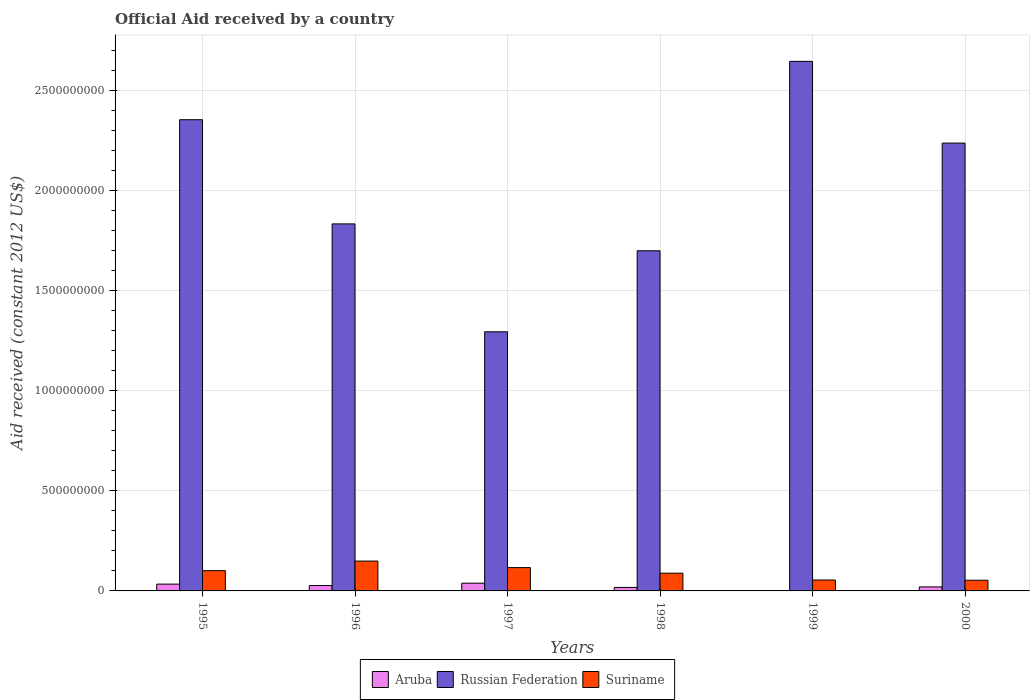How many different coloured bars are there?
Make the answer very short. 3. How many groups of bars are there?
Your answer should be very brief. 6. Are the number of bars on each tick of the X-axis equal?
Provide a short and direct response. No. How many bars are there on the 2nd tick from the left?
Offer a terse response. 3. In how many cases, is the number of bars for a given year not equal to the number of legend labels?
Offer a very short reply. 1. What is the net official aid received in Aruba in 1995?
Offer a very short reply. 3.40e+07. Across all years, what is the maximum net official aid received in Aruba?
Keep it short and to the point. 3.87e+07. Across all years, what is the minimum net official aid received in Aruba?
Provide a succinct answer. 0. What is the total net official aid received in Suriname in the graph?
Keep it short and to the point. 5.64e+08. What is the difference between the net official aid received in Russian Federation in 1996 and that in 1998?
Give a very brief answer. 1.34e+08. What is the difference between the net official aid received in Russian Federation in 1998 and the net official aid received in Aruba in 1995?
Your answer should be compact. 1.67e+09. What is the average net official aid received in Suriname per year?
Make the answer very short. 9.39e+07. In the year 1995, what is the difference between the net official aid received in Russian Federation and net official aid received in Aruba?
Ensure brevity in your answer.  2.32e+09. What is the ratio of the net official aid received in Russian Federation in 1997 to that in 1999?
Keep it short and to the point. 0.49. Is the difference between the net official aid received in Russian Federation in 1997 and 1998 greater than the difference between the net official aid received in Aruba in 1997 and 1998?
Offer a terse response. No. What is the difference between the highest and the second highest net official aid received in Russian Federation?
Offer a very short reply. 2.92e+08. What is the difference between the highest and the lowest net official aid received in Suriname?
Your answer should be very brief. 9.58e+07. Is it the case that in every year, the sum of the net official aid received in Aruba and net official aid received in Suriname is greater than the net official aid received in Russian Federation?
Your answer should be compact. No. How many bars are there?
Ensure brevity in your answer.  17. How many years are there in the graph?
Offer a terse response. 6. What is the difference between two consecutive major ticks on the Y-axis?
Offer a terse response. 5.00e+08. Are the values on the major ticks of Y-axis written in scientific E-notation?
Your answer should be compact. No. Does the graph contain any zero values?
Keep it short and to the point. Yes. Does the graph contain grids?
Your answer should be very brief. Yes. How are the legend labels stacked?
Your response must be concise. Horizontal. What is the title of the graph?
Your response must be concise. Official Aid received by a country. Does "Lao PDR" appear as one of the legend labels in the graph?
Give a very brief answer. No. What is the label or title of the X-axis?
Provide a succinct answer. Years. What is the label or title of the Y-axis?
Make the answer very short. Aid received (constant 2012 US$). What is the Aid received (constant 2012 US$) of Aruba in 1995?
Provide a succinct answer. 3.40e+07. What is the Aid received (constant 2012 US$) of Russian Federation in 1995?
Offer a very short reply. 2.36e+09. What is the Aid received (constant 2012 US$) in Suriname in 1995?
Provide a short and direct response. 1.01e+08. What is the Aid received (constant 2012 US$) of Aruba in 1996?
Provide a succinct answer. 2.68e+07. What is the Aid received (constant 2012 US$) in Russian Federation in 1996?
Offer a terse response. 1.84e+09. What is the Aid received (constant 2012 US$) in Suriname in 1996?
Provide a short and direct response. 1.49e+08. What is the Aid received (constant 2012 US$) of Aruba in 1997?
Keep it short and to the point. 3.87e+07. What is the Aid received (constant 2012 US$) in Russian Federation in 1997?
Make the answer very short. 1.30e+09. What is the Aid received (constant 2012 US$) of Suriname in 1997?
Give a very brief answer. 1.17e+08. What is the Aid received (constant 2012 US$) in Aruba in 1998?
Keep it short and to the point. 1.74e+07. What is the Aid received (constant 2012 US$) in Russian Federation in 1998?
Give a very brief answer. 1.70e+09. What is the Aid received (constant 2012 US$) of Suriname in 1998?
Ensure brevity in your answer.  8.86e+07. What is the Aid received (constant 2012 US$) of Russian Federation in 1999?
Your answer should be compact. 2.65e+09. What is the Aid received (constant 2012 US$) in Suriname in 1999?
Make the answer very short. 5.45e+07. What is the Aid received (constant 2012 US$) of Aruba in 2000?
Your answer should be compact. 2.01e+07. What is the Aid received (constant 2012 US$) in Russian Federation in 2000?
Your answer should be compact. 2.24e+09. What is the Aid received (constant 2012 US$) of Suriname in 2000?
Your answer should be very brief. 5.34e+07. Across all years, what is the maximum Aid received (constant 2012 US$) in Aruba?
Your response must be concise. 3.87e+07. Across all years, what is the maximum Aid received (constant 2012 US$) in Russian Federation?
Provide a short and direct response. 2.65e+09. Across all years, what is the maximum Aid received (constant 2012 US$) of Suriname?
Provide a short and direct response. 1.49e+08. Across all years, what is the minimum Aid received (constant 2012 US$) of Aruba?
Provide a succinct answer. 0. Across all years, what is the minimum Aid received (constant 2012 US$) of Russian Federation?
Offer a terse response. 1.30e+09. Across all years, what is the minimum Aid received (constant 2012 US$) in Suriname?
Your answer should be compact. 5.34e+07. What is the total Aid received (constant 2012 US$) of Aruba in the graph?
Offer a very short reply. 1.37e+08. What is the total Aid received (constant 2012 US$) of Russian Federation in the graph?
Offer a very short reply. 1.21e+1. What is the total Aid received (constant 2012 US$) in Suriname in the graph?
Offer a terse response. 5.64e+08. What is the difference between the Aid received (constant 2012 US$) in Aruba in 1995 and that in 1996?
Give a very brief answer. 7.17e+06. What is the difference between the Aid received (constant 2012 US$) of Russian Federation in 1995 and that in 1996?
Offer a terse response. 5.21e+08. What is the difference between the Aid received (constant 2012 US$) of Suriname in 1995 and that in 1996?
Offer a terse response. -4.78e+07. What is the difference between the Aid received (constant 2012 US$) in Aruba in 1995 and that in 1997?
Make the answer very short. -4.66e+06. What is the difference between the Aid received (constant 2012 US$) in Russian Federation in 1995 and that in 1997?
Give a very brief answer. 1.06e+09. What is the difference between the Aid received (constant 2012 US$) in Suriname in 1995 and that in 1997?
Your response must be concise. -1.52e+07. What is the difference between the Aid received (constant 2012 US$) in Aruba in 1995 and that in 1998?
Offer a very short reply. 1.67e+07. What is the difference between the Aid received (constant 2012 US$) of Russian Federation in 1995 and that in 1998?
Offer a very short reply. 6.55e+08. What is the difference between the Aid received (constant 2012 US$) of Suriname in 1995 and that in 1998?
Keep it short and to the point. 1.28e+07. What is the difference between the Aid received (constant 2012 US$) in Russian Federation in 1995 and that in 1999?
Give a very brief answer. -2.92e+08. What is the difference between the Aid received (constant 2012 US$) of Suriname in 1995 and that in 1999?
Your response must be concise. 4.69e+07. What is the difference between the Aid received (constant 2012 US$) of Aruba in 1995 and that in 2000?
Make the answer very short. 1.39e+07. What is the difference between the Aid received (constant 2012 US$) of Russian Federation in 1995 and that in 2000?
Ensure brevity in your answer.  1.17e+08. What is the difference between the Aid received (constant 2012 US$) in Suriname in 1995 and that in 2000?
Provide a short and direct response. 4.80e+07. What is the difference between the Aid received (constant 2012 US$) of Aruba in 1996 and that in 1997?
Offer a terse response. -1.18e+07. What is the difference between the Aid received (constant 2012 US$) of Russian Federation in 1996 and that in 1997?
Provide a succinct answer. 5.39e+08. What is the difference between the Aid received (constant 2012 US$) of Suriname in 1996 and that in 1997?
Keep it short and to the point. 3.26e+07. What is the difference between the Aid received (constant 2012 US$) of Aruba in 1996 and that in 1998?
Make the answer very short. 9.50e+06. What is the difference between the Aid received (constant 2012 US$) in Russian Federation in 1996 and that in 1998?
Your answer should be very brief. 1.34e+08. What is the difference between the Aid received (constant 2012 US$) of Suriname in 1996 and that in 1998?
Provide a short and direct response. 6.06e+07. What is the difference between the Aid received (constant 2012 US$) of Russian Federation in 1996 and that in 1999?
Provide a short and direct response. -8.13e+08. What is the difference between the Aid received (constant 2012 US$) in Suriname in 1996 and that in 1999?
Your answer should be compact. 9.46e+07. What is the difference between the Aid received (constant 2012 US$) of Aruba in 1996 and that in 2000?
Offer a very short reply. 6.72e+06. What is the difference between the Aid received (constant 2012 US$) in Russian Federation in 1996 and that in 2000?
Keep it short and to the point. -4.04e+08. What is the difference between the Aid received (constant 2012 US$) in Suriname in 1996 and that in 2000?
Offer a terse response. 9.58e+07. What is the difference between the Aid received (constant 2012 US$) in Aruba in 1997 and that in 1998?
Offer a terse response. 2.13e+07. What is the difference between the Aid received (constant 2012 US$) in Russian Federation in 1997 and that in 1998?
Your response must be concise. -4.05e+08. What is the difference between the Aid received (constant 2012 US$) of Suriname in 1997 and that in 1998?
Make the answer very short. 2.80e+07. What is the difference between the Aid received (constant 2012 US$) of Russian Federation in 1997 and that in 1999?
Your response must be concise. -1.35e+09. What is the difference between the Aid received (constant 2012 US$) of Suriname in 1997 and that in 1999?
Provide a short and direct response. 6.21e+07. What is the difference between the Aid received (constant 2012 US$) of Aruba in 1997 and that in 2000?
Ensure brevity in your answer.  1.86e+07. What is the difference between the Aid received (constant 2012 US$) of Russian Federation in 1997 and that in 2000?
Offer a terse response. -9.44e+08. What is the difference between the Aid received (constant 2012 US$) of Suriname in 1997 and that in 2000?
Your answer should be compact. 6.32e+07. What is the difference between the Aid received (constant 2012 US$) in Russian Federation in 1998 and that in 1999?
Give a very brief answer. -9.47e+08. What is the difference between the Aid received (constant 2012 US$) in Suriname in 1998 and that in 1999?
Keep it short and to the point. 3.41e+07. What is the difference between the Aid received (constant 2012 US$) of Aruba in 1998 and that in 2000?
Keep it short and to the point. -2.78e+06. What is the difference between the Aid received (constant 2012 US$) of Russian Federation in 1998 and that in 2000?
Ensure brevity in your answer.  -5.38e+08. What is the difference between the Aid received (constant 2012 US$) in Suriname in 1998 and that in 2000?
Offer a terse response. 3.52e+07. What is the difference between the Aid received (constant 2012 US$) in Russian Federation in 1999 and that in 2000?
Give a very brief answer. 4.09e+08. What is the difference between the Aid received (constant 2012 US$) of Suriname in 1999 and that in 2000?
Offer a very short reply. 1.18e+06. What is the difference between the Aid received (constant 2012 US$) of Aruba in 1995 and the Aid received (constant 2012 US$) of Russian Federation in 1996?
Your response must be concise. -1.80e+09. What is the difference between the Aid received (constant 2012 US$) in Aruba in 1995 and the Aid received (constant 2012 US$) in Suriname in 1996?
Ensure brevity in your answer.  -1.15e+08. What is the difference between the Aid received (constant 2012 US$) of Russian Federation in 1995 and the Aid received (constant 2012 US$) of Suriname in 1996?
Make the answer very short. 2.21e+09. What is the difference between the Aid received (constant 2012 US$) of Aruba in 1995 and the Aid received (constant 2012 US$) of Russian Federation in 1997?
Your response must be concise. -1.26e+09. What is the difference between the Aid received (constant 2012 US$) of Aruba in 1995 and the Aid received (constant 2012 US$) of Suriname in 1997?
Give a very brief answer. -8.26e+07. What is the difference between the Aid received (constant 2012 US$) in Russian Federation in 1995 and the Aid received (constant 2012 US$) in Suriname in 1997?
Give a very brief answer. 2.24e+09. What is the difference between the Aid received (constant 2012 US$) in Aruba in 1995 and the Aid received (constant 2012 US$) in Russian Federation in 1998?
Provide a succinct answer. -1.67e+09. What is the difference between the Aid received (constant 2012 US$) of Aruba in 1995 and the Aid received (constant 2012 US$) of Suriname in 1998?
Offer a very short reply. -5.46e+07. What is the difference between the Aid received (constant 2012 US$) in Russian Federation in 1995 and the Aid received (constant 2012 US$) in Suriname in 1998?
Offer a very short reply. 2.27e+09. What is the difference between the Aid received (constant 2012 US$) in Aruba in 1995 and the Aid received (constant 2012 US$) in Russian Federation in 1999?
Keep it short and to the point. -2.61e+09. What is the difference between the Aid received (constant 2012 US$) in Aruba in 1995 and the Aid received (constant 2012 US$) in Suriname in 1999?
Ensure brevity in your answer.  -2.05e+07. What is the difference between the Aid received (constant 2012 US$) of Russian Federation in 1995 and the Aid received (constant 2012 US$) of Suriname in 1999?
Give a very brief answer. 2.30e+09. What is the difference between the Aid received (constant 2012 US$) of Aruba in 1995 and the Aid received (constant 2012 US$) of Russian Federation in 2000?
Your answer should be very brief. -2.21e+09. What is the difference between the Aid received (constant 2012 US$) in Aruba in 1995 and the Aid received (constant 2012 US$) in Suriname in 2000?
Keep it short and to the point. -1.93e+07. What is the difference between the Aid received (constant 2012 US$) of Russian Federation in 1995 and the Aid received (constant 2012 US$) of Suriname in 2000?
Your answer should be compact. 2.30e+09. What is the difference between the Aid received (constant 2012 US$) of Aruba in 1996 and the Aid received (constant 2012 US$) of Russian Federation in 1997?
Your response must be concise. -1.27e+09. What is the difference between the Aid received (constant 2012 US$) in Aruba in 1996 and the Aid received (constant 2012 US$) in Suriname in 1997?
Provide a succinct answer. -8.98e+07. What is the difference between the Aid received (constant 2012 US$) of Russian Federation in 1996 and the Aid received (constant 2012 US$) of Suriname in 1997?
Give a very brief answer. 1.72e+09. What is the difference between the Aid received (constant 2012 US$) of Aruba in 1996 and the Aid received (constant 2012 US$) of Russian Federation in 1998?
Offer a very short reply. -1.67e+09. What is the difference between the Aid received (constant 2012 US$) of Aruba in 1996 and the Aid received (constant 2012 US$) of Suriname in 1998?
Offer a terse response. -6.18e+07. What is the difference between the Aid received (constant 2012 US$) in Russian Federation in 1996 and the Aid received (constant 2012 US$) in Suriname in 1998?
Offer a terse response. 1.75e+09. What is the difference between the Aid received (constant 2012 US$) in Aruba in 1996 and the Aid received (constant 2012 US$) in Russian Federation in 1999?
Ensure brevity in your answer.  -2.62e+09. What is the difference between the Aid received (constant 2012 US$) in Aruba in 1996 and the Aid received (constant 2012 US$) in Suriname in 1999?
Make the answer very short. -2.77e+07. What is the difference between the Aid received (constant 2012 US$) of Russian Federation in 1996 and the Aid received (constant 2012 US$) of Suriname in 1999?
Give a very brief answer. 1.78e+09. What is the difference between the Aid received (constant 2012 US$) in Aruba in 1996 and the Aid received (constant 2012 US$) in Russian Federation in 2000?
Your response must be concise. -2.21e+09. What is the difference between the Aid received (constant 2012 US$) of Aruba in 1996 and the Aid received (constant 2012 US$) of Suriname in 2000?
Keep it short and to the point. -2.65e+07. What is the difference between the Aid received (constant 2012 US$) of Russian Federation in 1996 and the Aid received (constant 2012 US$) of Suriname in 2000?
Offer a very short reply. 1.78e+09. What is the difference between the Aid received (constant 2012 US$) of Aruba in 1997 and the Aid received (constant 2012 US$) of Russian Federation in 1998?
Ensure brevity in your answer.  -1.66e+09. What is the difference between the Aid received (constant 2012 US$) in Aruba in 1997 and the Aid received (constant 2012 US$) in Suriname in 1998?
Ensure brevity in your answer.  -4.99e+07. What is the difference between the Aid received (constant 2012 US$) of Russian Federation in 1997 and the Aid received (constant 2012 US$) of Suriname in 1998?
Ensure brevity in your answer.  1.21e+09. What is the difference between the Aid received (constant 2012 US$) of Aruba in 1997 and the Aid received (constant 2012 US$) of Russian Federation in 1999?
Offer a terse response. -2.61e+09. What is the difference between the Aid received (constant 2012 US$) in Aruba in 1997 and the Aid received (constant 2012 US$) in Suriname in 1999?
Offer a terse response. -1.59e+07. What is the difference between the Aid received (constant 2012 US$) of Russian Federation in 1997 and the Aid received (constant 2012 US$) of Suriname in 1999?
Provide a short and direct response. 1.24e+09. What is the difference between the Aid received (constant 2012 US$) of Aruba in 1997 and the Aid received (constant 2012 US$) of Russian Federation in 2000?
Provide a succinct answer. -2.20e+09. What is the difference between the Aid received (constant 2012 US$) in Aruba in 1997 and the Aid received (constant 2012 US$) in Suriname in 2000?
Provide a short and direct response. -1.47e+07. What is the difference between the Aid received (constant 2012 US$) in Russian Federation in 1997 and the Aid received (constant 2012 US$) in Suriname in 2000?
Your answer should be very brief. 1.24e+09. What is the difference between the Aid received (constant 2012 US$) in Aruba in 1998 and the Aid received (constant 2012 US$) in Russian Federation in 1999?
Provide a short and direct response. -2.63e+09. What is the difference between the Aid received (constant 2012 US$) in Aruba in 1998 and the Aid received (constant 2012 US$) in Suriname in 1999?
Your response must be concise. -3.72e+07. What is the difference between the Aid received (constant 2012 US$) of Russian Federation in 1998 and the Aid received (constant 2012 US$) of Suriname in 1999?
Offer a very short reply. 1.65e+09. What is the difference between the Aid received (constant 2012 US$) of Aruba in 1998 and the Aid received (constant 2012 US$) of Russian Federation in 2000?
Offer a terse response. -2.22e+09. What is the difference between the Aid received (constant 2012 US$) in Aruba in 1998 and the Aid received (constant 2012 US$) in Suriname in 2000?
Provide a short and direct response. -3.60e+07. What is the difference between the Aid received (constant 2012 US$) of Russian Federation in 1998 and the Aid received (constant 2012 US$) of Suriname in 2000?
Provide a short and direct response. 1.65e+09. What is the difference between the Aid received (constant 2012 US$) of Russian Federation in 1999 and the Aid received (constant 2012 US$) of Suriname in 2000?
Keep it short and to the point. 2.59e+09. What is the average Aid received (constant 2012 US$) of Aruba per year?
Offer a terse response. 2.28e+07. What is the average Aid received (constant 2012 US$) of Russian Federation per year?
Your response must be concise. 2.01e+09. What is the average Aid received (constant 2012 US$) of Suriname per year?
Provide a succinct answer. 9.39e+07. In the year 1995, what is the difference between the Aid received (constant 2012 US$) in Aruba and Aid received (constant 2012 US$) in Russian Federation?
Provide a short and direct response. -2.32e+09. In the year 1995, what is the difference between the Aid received (constant 2012 US$) of Aruba and Aid received (constant 2012 US$) of Suriname?
Provide a succinct answer. -6.74e+07. In the year 1995, what is the difference between the Aid received (constant 2012 US$) of Russian Federation and Aid received (constant 2012 US$) of Suriname?
Keep it short and to the point. 2.25e+09. In the year 1996, what is the difference between the Aid received (constant 2012 US$) of Aruba and Aid received (constant 2012 US$) of Russian Federation?
Give a very brief answer. -1.81e+09. In the year 1996, what is the difference between the Aid received (constant 2012 US$) of Aruba and Aid received (constant 2012 US$) of Suriname?
Make the answer very short. -1.22e+08. In the year 1996, what is the difference between the Aid received (constant 2012 US$) in Russian Federation and Aid received (constant 2012 US$) in Suriname?
Provide a succinct answer. 1.69e+09. In the year 1997, what is the difference between the Aid received (constant 2012 US$) of Aruba and Aid received (constant 2012 US$) of Russian Federation?
Provide a short and direct response. -1.26e+09. In the year 1997, what is the difference between the Aid received (constant 2012 US$) in Aruba and Aid received (constant 2012 US$) in Suriname?
Ensure brevity in your answer.  -7.79e+07. In the year 1997, what is the difference between the Aid received (constant 2012 US$) in Russian Federation and Aid received (constant 2012 US$) in Suriname?
Give a very brief answer. 1.18e+09. In the year 1998, what is the difference between the Aid received (constant 2012 US$) in Aruba and Aid received (constant 2012 US$) in Russian Federation?
Your answer should be compact. -1.68e+09. In the year 1998, what is the difference between the Aid received (constant 2012 US$) in Aruba and Aid received (constant 2012 US$) in Suriname?
Your answer should be very brief. -7.12e+07. In the year 1998, what is the difference between the Aid received (constant 2012 US$) of Russian Federation and Aid received (constant 2012 US$) of Suriname?
Make the answer very short. 1.61e+09. In the year 1999, what is the difference between the Aid received (constant 2012 US$) in Russian Federation and Aid received (constant 2012 US$) in Suriname?
Make the answer very short. 2.59e+09. In the year 2000, what is the difference between the Aid received (constant 2012 US$) in Aruba and Aid received (constant 2012 US$) in Russian Federation?
Offer a terse response. -2.22e+09. In the year 2000, what is the difference between the Aid received (constant 2012 US$) in Aruba and Aid received (constant 2012 US$) in Suriname?
Ensure brevity in your answer.  -3.32e+07. In the year 2000, what is the difference between the Aid received (constant 2012 US$) in Russian Federation and Aid received (constant 2012 US$) in Suriname?
Keep it short and to the point. 2.19e+09. What is the ratio of the Aid received (constant 2012 US$) in Aruba in 1995 to that in 1996?
Your answer should be very brief. 1.27. What is the ratio of the Aid received (constant 2012 US$) in Russian Federation in 1995 to that in 1996?
Make the answer very short. 1.28. What is the ratio of the Aid received (constant 2012 US$) of Suriname in 1995 to that in 1996?
Offer a terse response. 0.68. What is the ratio of the Aid received (constant 2012 US$) in Aruba in 1995 to that in 1997?
Your answer should be compact. 0.88. What is the ratio of the Aid received (constant 2012 US$) in Russian Federation in 1995 to that in 1997?
Keep it short and to the point. 1.82. What is the ratio of the Aid received (constant 2012 US$) of Suriname in 1995 to that in 1997?
Keep it short and to the point. 0.87. What is the ratio of the Aid received (constant 2012 US$) in Aruba in 1995 to that in 1998?
Your answer should be compact. 1.96. What is the ratio of the Aid received (constant 2012 US$) of Russian Federation in 1995 to that in 1998?
Offer a terse response. 1.39. What is the ratio of the Aid received (constant 2012 US$) of Suriname in 1995 to that in 1998?
Ensure brevity in your answer.  1.14. What is the ratio of the Aid received (constant 2012 US$) of Russian Federation in 1995 to that in 1999?
Your answer should be very brief. 0.89. What is the ratio of the Aid received (constant 2012 US$) in Suriname in 1995 to that in 1999?
Give a very brief answer. 1.86. What is the ratio of the Aid received (constant 2012 US$) in Aruba in 1995 to that in 2000?
Keep it short and to the point. 1.69. What is the ratio of the Aid received (constant 2012 US$) of Russian Federation in 1995 to that in 2000?
Offer a very short reply. 1.05. What is the ratio of the Aid received (constant 2012 US$) in Suriname in 1995 to that in 2000?
Your response must be concise. 1.9. What is the ratio of the Aid received (constant 2012 US$) in Aruba in 1996 to that in 1997?
Your answer should be very brief. 0.69. What is the ratio of the Aid received (constant 2012 US$) of Russian Federation in 1996 to that in 1997?
Make the answer very short. 1.42. What is the ratio of the Aid received (constant 2012 US$) of Suriname in 1996 to that in 1997?
Give a very brief answer. 1.28. What is the ratio of the Aid received (constant 2012 US$) in Aruba in 1996 to that in 1998?
Give a very brief answer. 1.55. What is the ratio of the Aid received (constant 2012 US$) in Russian Federation in 1996 to that in 1998?
Your answer should be very brief. 1.08. What is the ratio of the Aid received (constant 2012 US$) of Suriname in 1996 to that in 1998?
Make the answer very short. 1.68. What is the ratio of the Aid received (constant 2012 US$) in Russian Federation in 1996 to that in 1999?
Your answer should be very brief. 0.69. What is the ratio of the Aid received (constant 2012 US$) in Suriname in 1996 to that in 1999?
Give a very brief answer. 2.74. What is the ratio of the Aid received (constant 2012 US$) in Aruba in 1996 to that in 2000?
Your response must be concise. 1.33. What is the ratio of the Aid received (constant 2012 US$) of Russian Federation in 1996 to that in 2000?
Your answer should be compact. 0.82. What is the ratio of the Aid received (constant 2012 US$) of Suriname in 1996 to that in 2000?
Give a very brief answer. 2.8. What is the ratio of the Aid received (constant 2012 US$) of Aruba in 1997 to that in 1998?
Offer a terse response. 2.23. What is the ratio of the Aid received (constant 2012 US$) in Russian Federation in 1997 to that in 1998?
Provide a succinct answer. 0.76. What is the ratio of the Aid received (constant 2012 US$) of Suriname in 1997 to that in 1998?
Provide a short and direct response. 1.32. What is the ratio of the Aid received (constant 2012 US$) of Russian Federation in 1997 to that in 1999?
Provide a short and direct response. 0.49. What is the ratio of the Aid received (constant 2012 US$) of Suriname in 1997 to that in 1999?
Your response must be concise. 2.14. What is the ratio of the Aid received (constant 2012 US$) of Aruba in 1997 to that in 2000?
Your answer should be compact. 1.92. What is the ratio of the Aid received (constant 2012 US$) of Russian Federation in 1997 to that in 2000?
Give a very brief answer. 0.58. What is the ratio of the Aid received (constant 2012 US$) in Suriname in 1997 to that in 2000?
Ensure brevity in your answer.  2.19. What is the ratio of the Aid received (constant 2012 US$) of Russian Federation in 1998 to that in 1999?
Your answer should be very brief. 0.64. What is the ratio of the Aid received (constant 2012 US$) in Suriname in 1998 to that in 1999?
Your response must be concise. 1.62. What is the ratio of the Aid received (constant 2012 US$) in Aruba in 1998 to that in 2000?
Offer a very short reply. 0.86. What is the ratio of the Aid received (constant 2012 US$) in Russian Federation in 1998 to that in 2000?
Your response must be concise. 0.76. What is the ratio of the Aid received (constant 2012 US$) of Suriname in 1998 to that in 2000?
Your response must be concise. 1.66. What is the ratio of the Aid received (constant 2012 US$) in Russian Federation in 1999 to that in 2000?
Provide a short and direct response. 1.18. What is the ratio of the Aid received (constant 2012 US$) in Suriname in 1999 to that in 2000?
Keep it short and to the point. 1.02. What is the difference between the highest and the second highest Aid received (constant 2012 US$) of Aruba?
Your answer should be compact. 4.66e+06. What is the difference between the highest and the second highest Aid received (constant 2012 US$) of Russian Federation?
Ensure brevity in your answer.  2.92e+08. What is the difference between the highest and the second highest Aid received (constant 2012 US$) in Suriname?
Your response must be concise. 3.26e+07. What is the difference between the highest and the lowest Aid received (constant 2012 US$) of Aruba?
Provide a short and direct response. 3.87e+07. What is the difference between the highest and the lowest Aid received (constant 2012 US$) of Russian Federation?
Your answer should be compact. 1.35e+09. What is the difference between the highest and the lowest Aid received (constant 2012 US$) in Suriname?
Offer a terse response. 9.58e+07. 